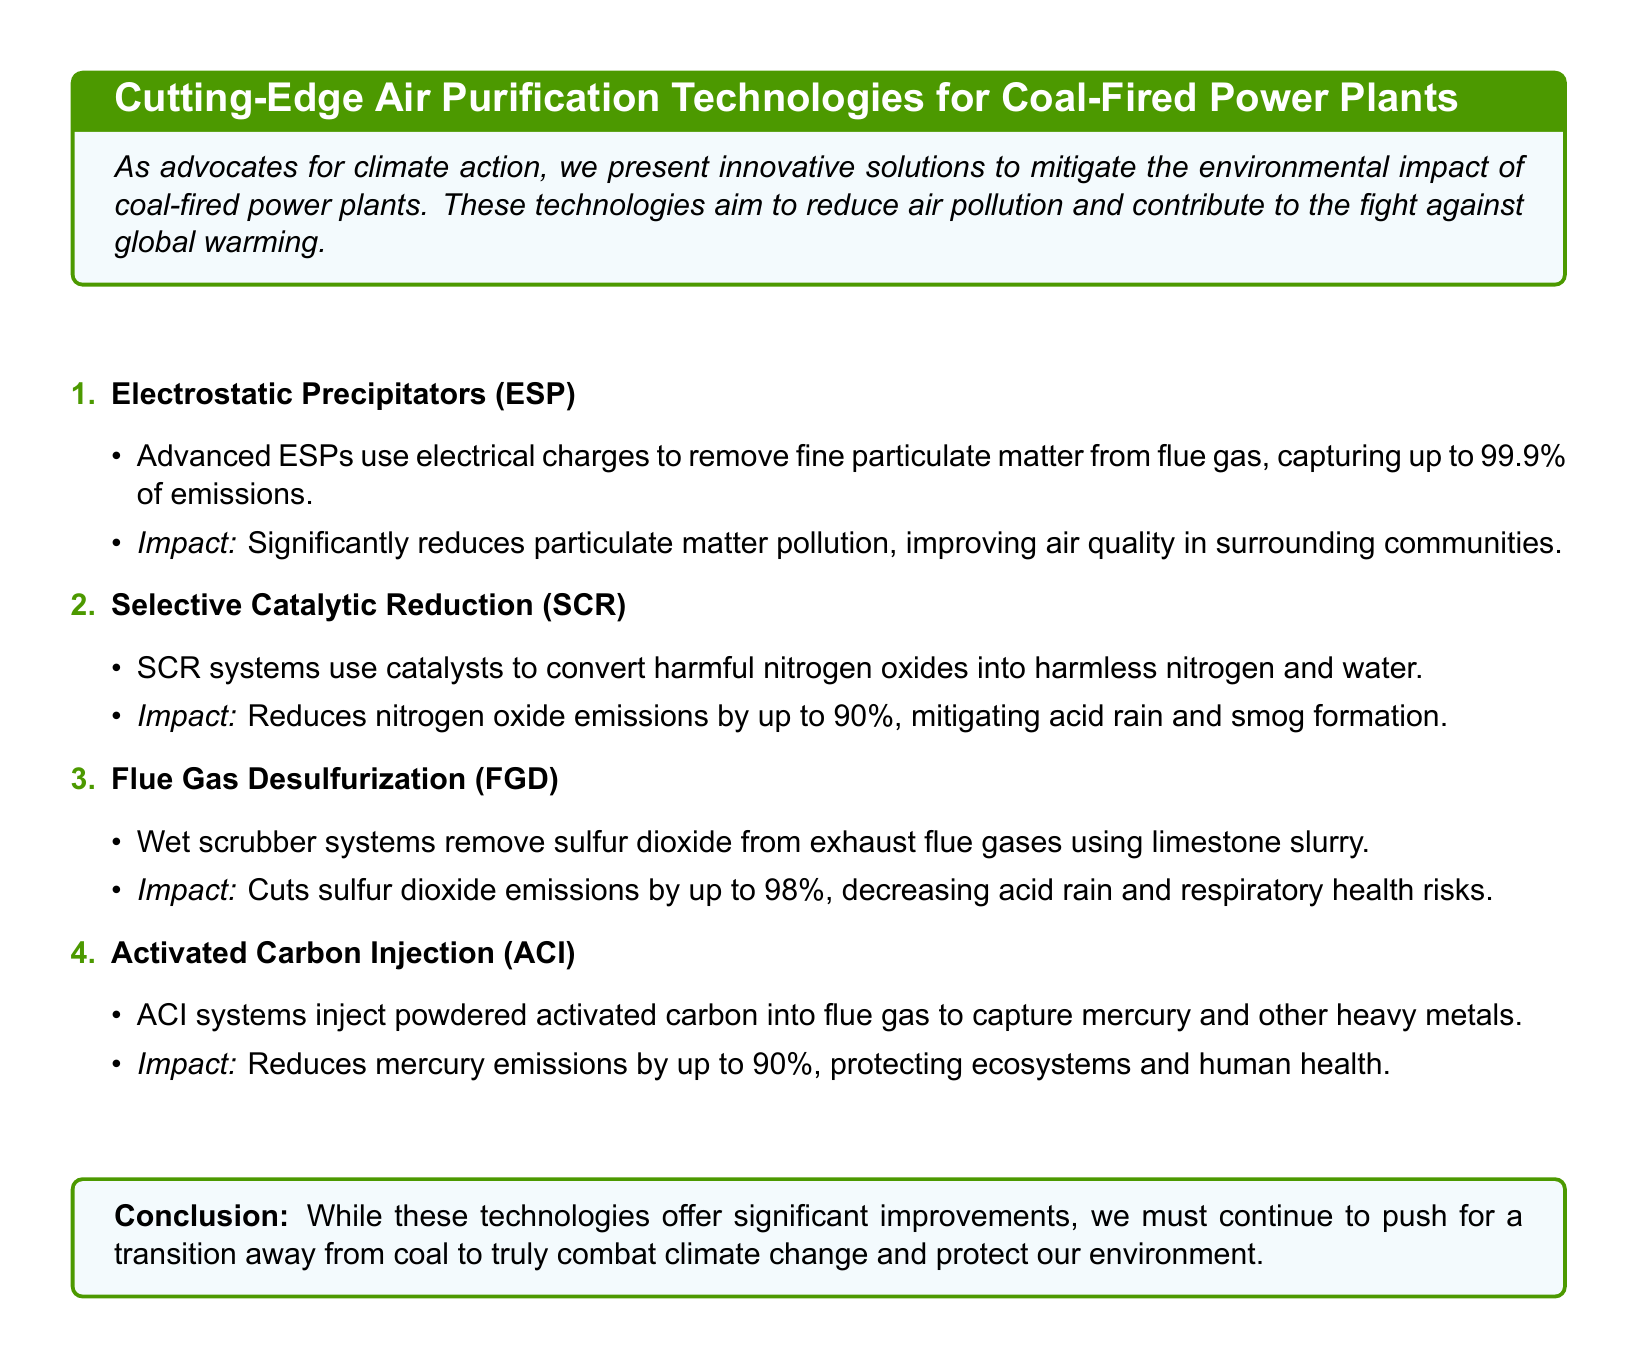what is the reduction percentage of nitrogen oxide emissions with SCR? The document states that SCR systems reduce nitrogen oxide emissions by up to 90%.
Answer: 90% what technology captures fine particulate matter from flue gas? The technology mentioned is Electrostatic Precipitators (ESP), which capture up to 99.9% of emissions.
Answer: Electrostatic Precipitators (ESP) what is the impact of Flue Gas Desulfurization (FGD)? The impact of FGD is to cut sulfur dioxide emissions by up to 98%, decreasing acid rain and respiratory health risks.
Answer: Cuts sulfur dioxide emissions by up to 98% how much mercury emissions does Activated Carbon Injection (ACI) reduce? The document indicates that ACI reduces mercury emissions by up to 90%.
Answer: 90% what is the main topic of the catalog? The main topic of the catalog is showcasing cutting-edge air purification technologies for coal-fired power plants.
Answer: Cutting-edge air purification technologies for coal-fired power plants what is the conclusion about these technologies? The conclusion states that while these technologies offer significant improvements, we must continue to push for a transition away from coal.
Answer: Transition away from coal what is the impact of Selective Catalytic Reduction (SCR) on smog formation? SCR mitigates acid rain and smog formation.
Answer: Mitigates acid rain and smog formation what is the function of Activated Carbon Injection (ACI)? ACI captures mercury and other heavy metals from flue gas.
Answer: Captures mercury and other heavy metals 